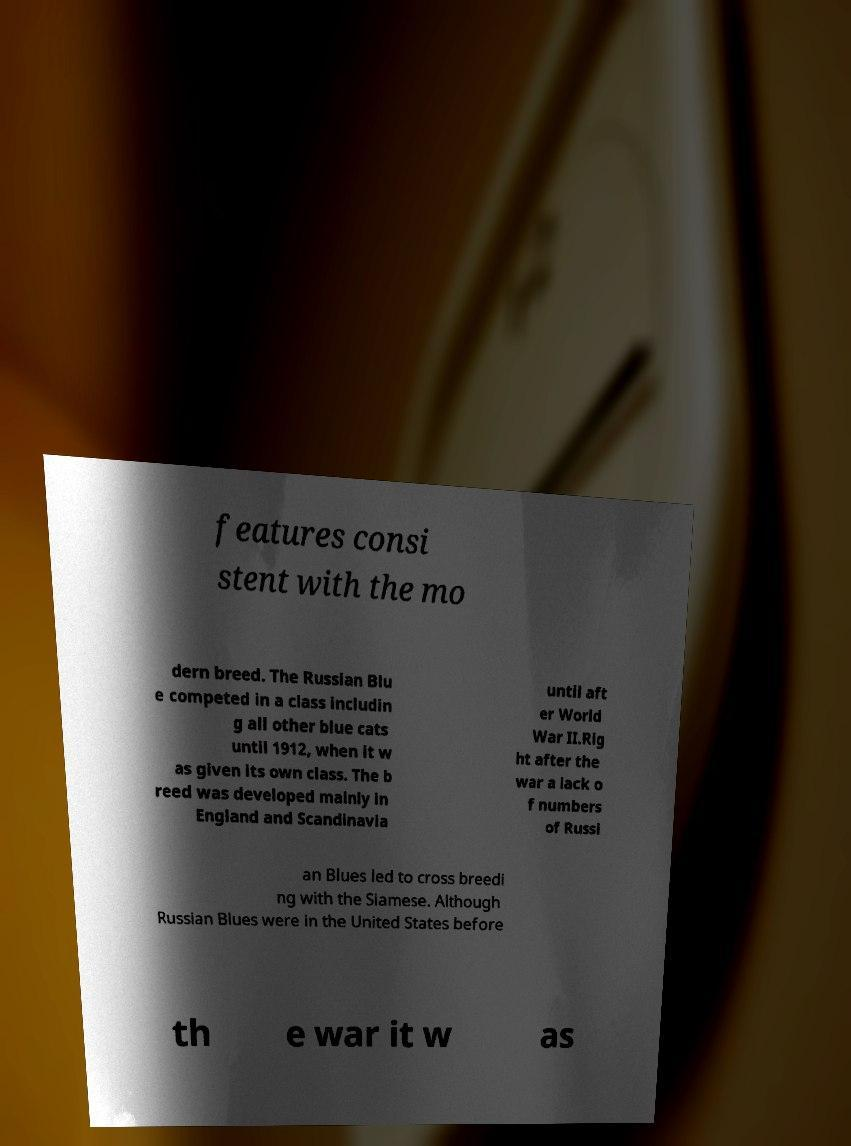For documentation purposes, I need the text within this image transcribed. Could you provide that? features consi stent with the mo dern breed. The Russian Blu e competed in a class includin g all other blue cats until 1912, when it w as given its own class. The b reed was developed mainly in England and Scandinavia until aft er World War II.Rig ht after the war a lack o f numbers of Russi an Blues led to cross breedi ng with the Siamese. Although Russian Blues were in the United States before th e war it w as 